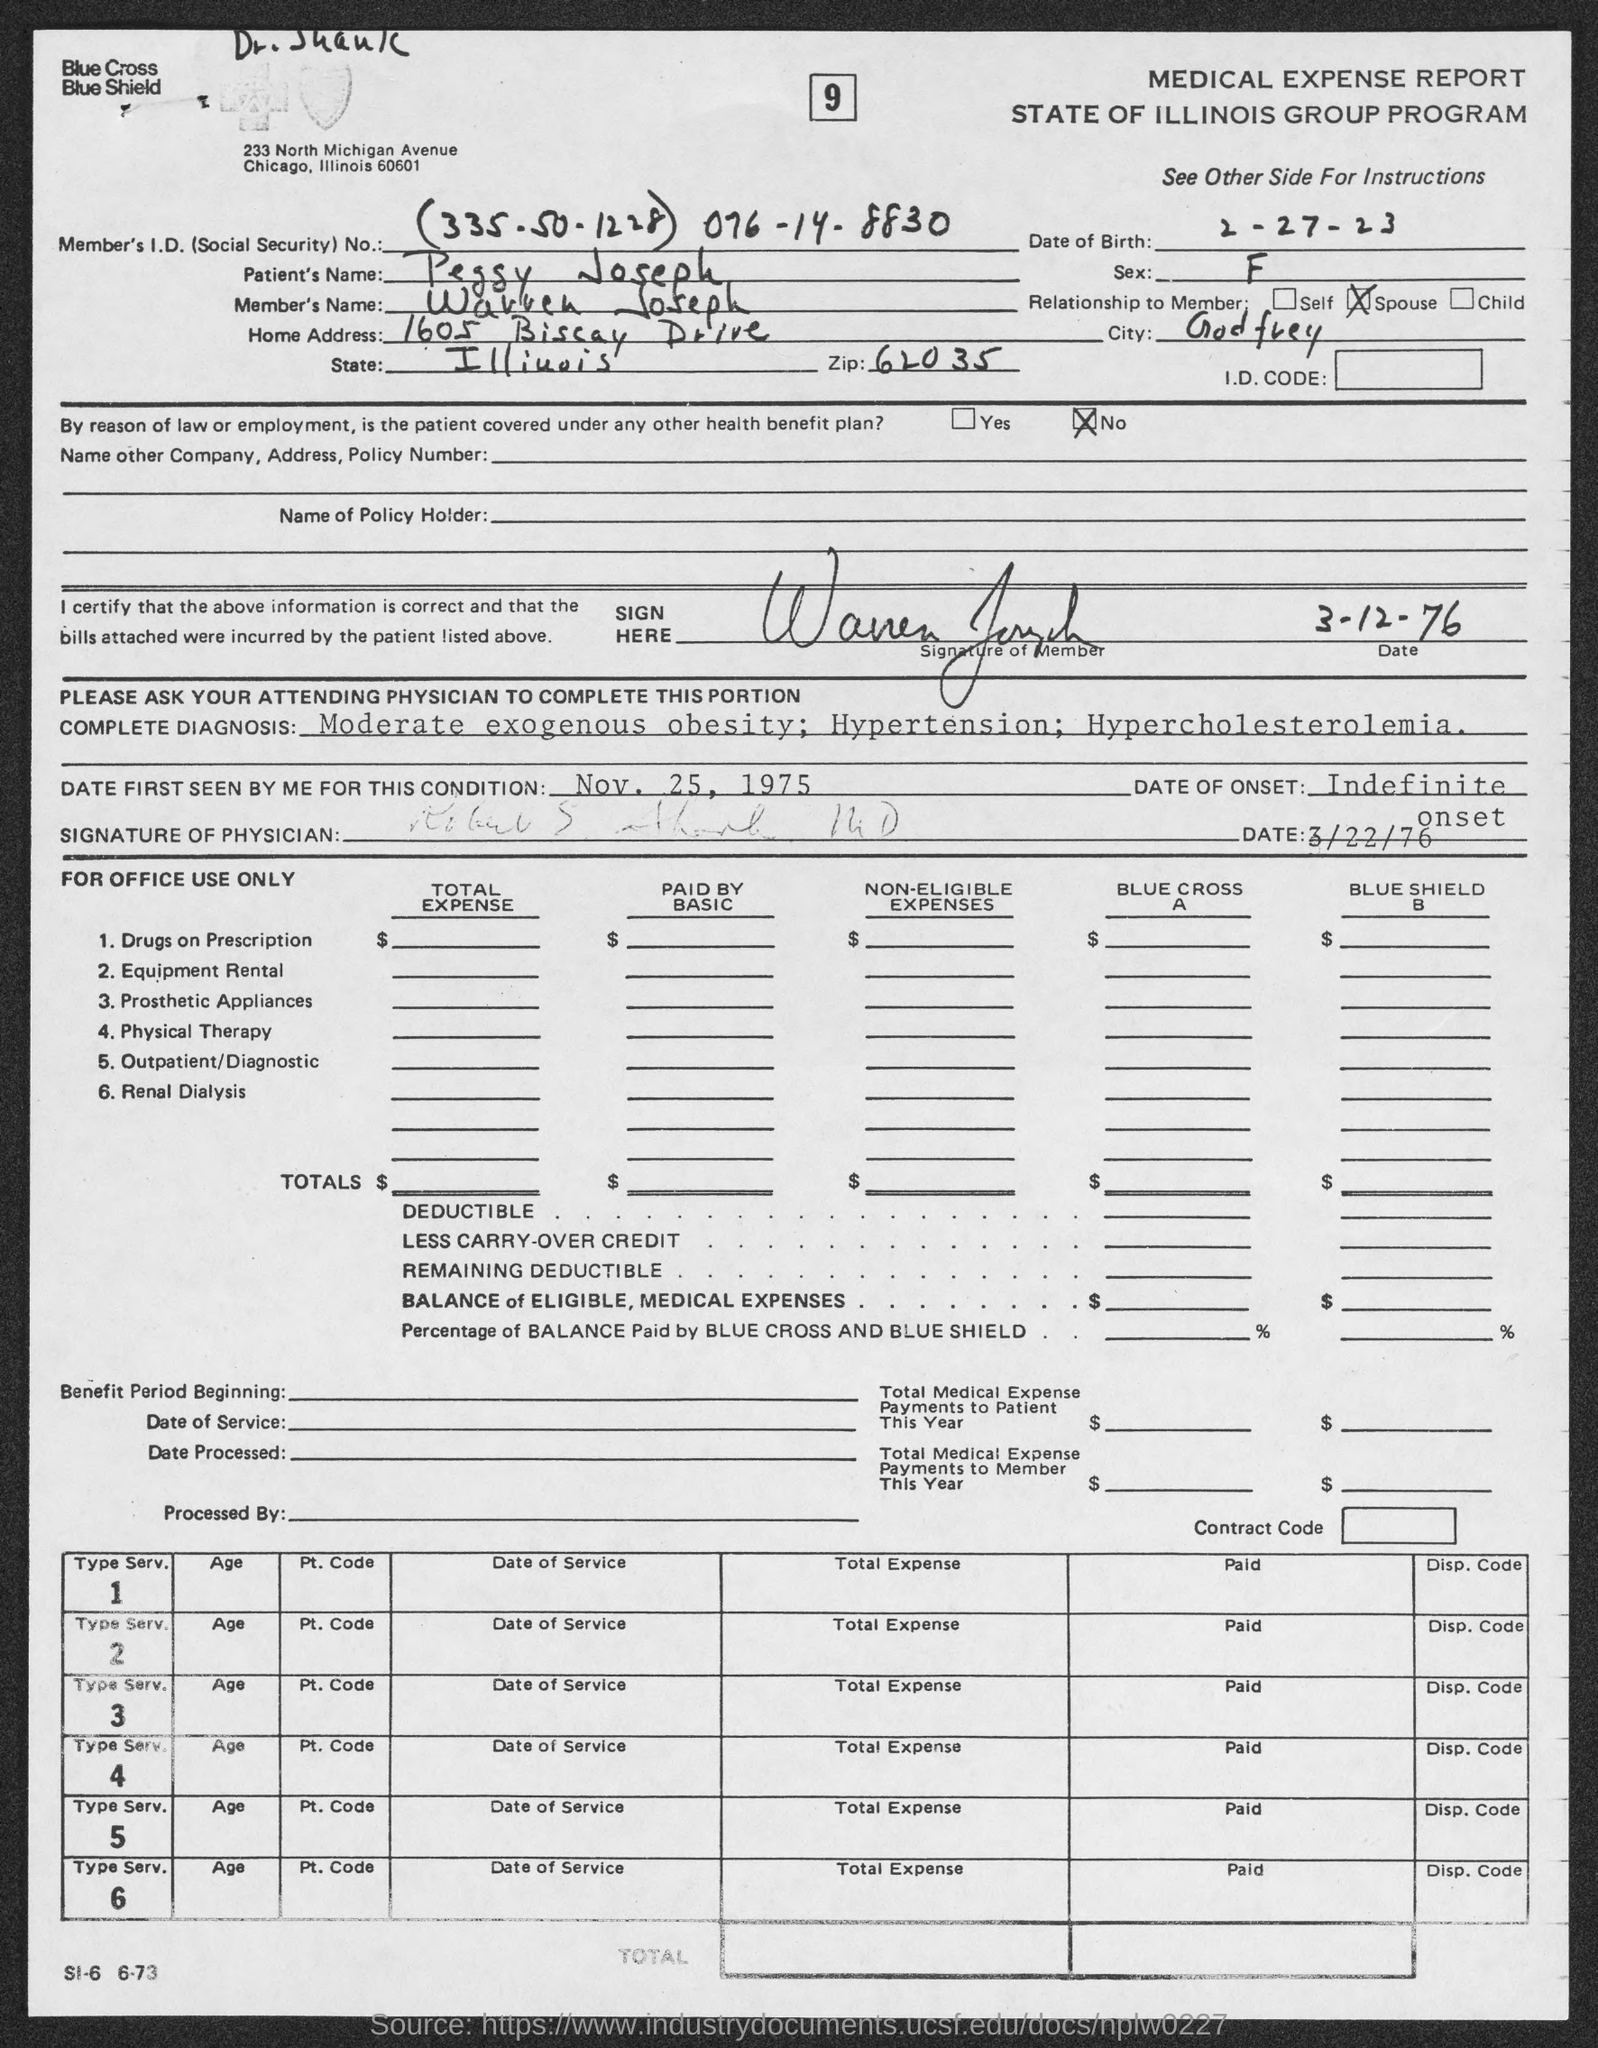What is the Date of Birth?
Your response must be concise. 2-27-23. What is the Patient's Name?
Your response must be concise. Peggy Joseph. What is the Member's Name?
Give a very brief answer. Wavven Joseph. What is the Home Address?
Provide a short and direct response. 1605 Biscay Drive. What is the City?
Your answer should be compact. Godfrey. What is the Zip?
Provide a short and direct response. 62035. What is the date first seen for this condition?
Your answer should be compact. Nov, 25, 1975. What is the Member's I.D. (Social Security) No.?
Give a very brief answer. (335.50.1228) 076-14-8830. What is the Date of onset?
Make the answer very short. Indefinite onset. 